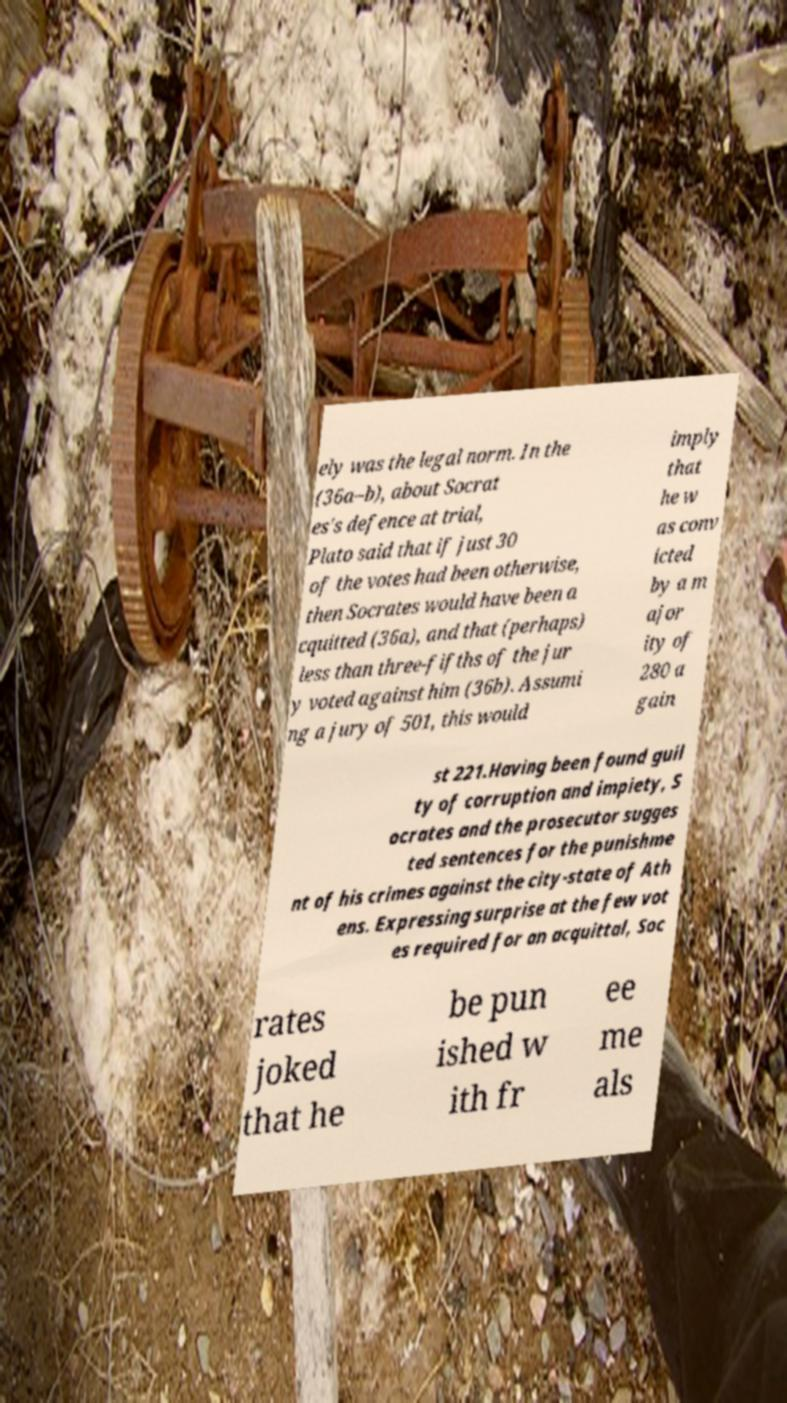Please read and relay the text visible in this image. What does it say? ely was the legal norm. In the (36a–b), about Socrat es's defence at trial, Plato said that if just 30 of the votes had been otherwise, then Socrates would have been a cquitted (36a), and that (perhaps) less than three-fifths of the jur y voted against him (36b). Assumi ng a jury of 501, this would imply that he w as conv icted by a m ajor ity of 280 a gain st 221.Having been found guil ty of corruption and impiety, S ocrates and the prosecutor sugges ted sentences for the punishme nt of his crimes against the city-state of Ath ens. Expressing surprise at the few vot es required for an acquittal, Soc rates joked that he be pun ished w ith fr ee me als 